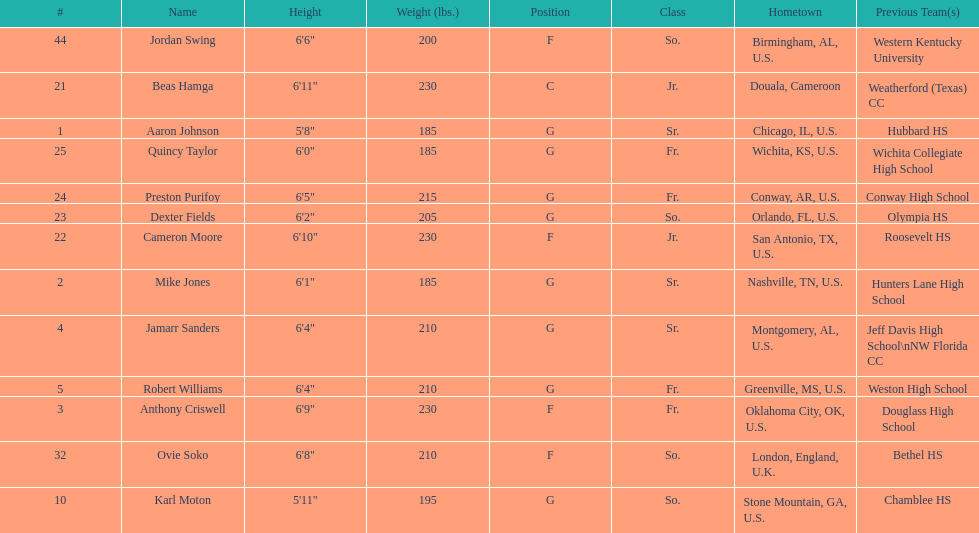How many players come from alabama? 2. 